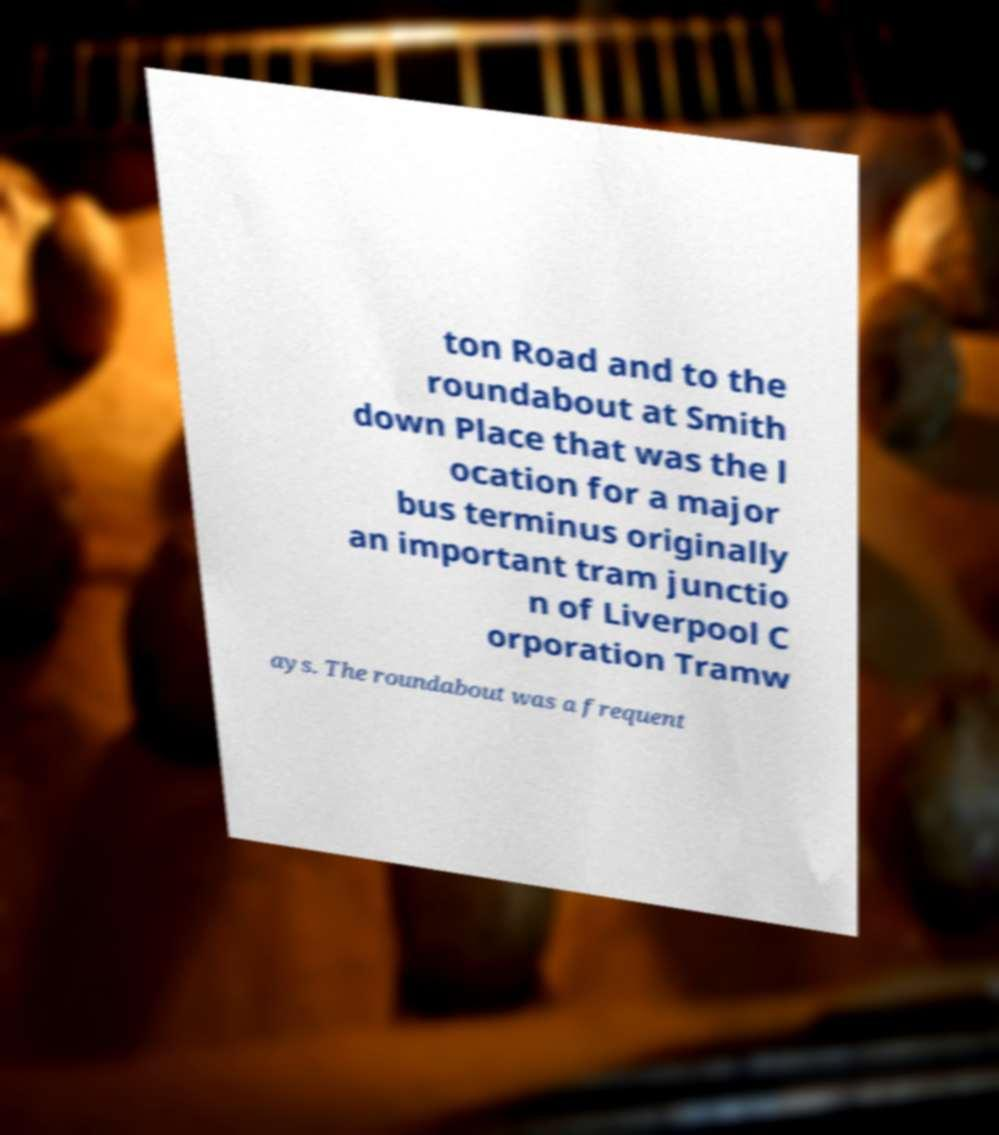What messages or text are displayed in this image? I need them in a readable, typed format. ton Road and to the roundabout at Smith down Place that was the l ocation for a major bus terminus originally an important tram junctio n of Liverpool C orporation Tramw ays. The roundabout was a frequent 